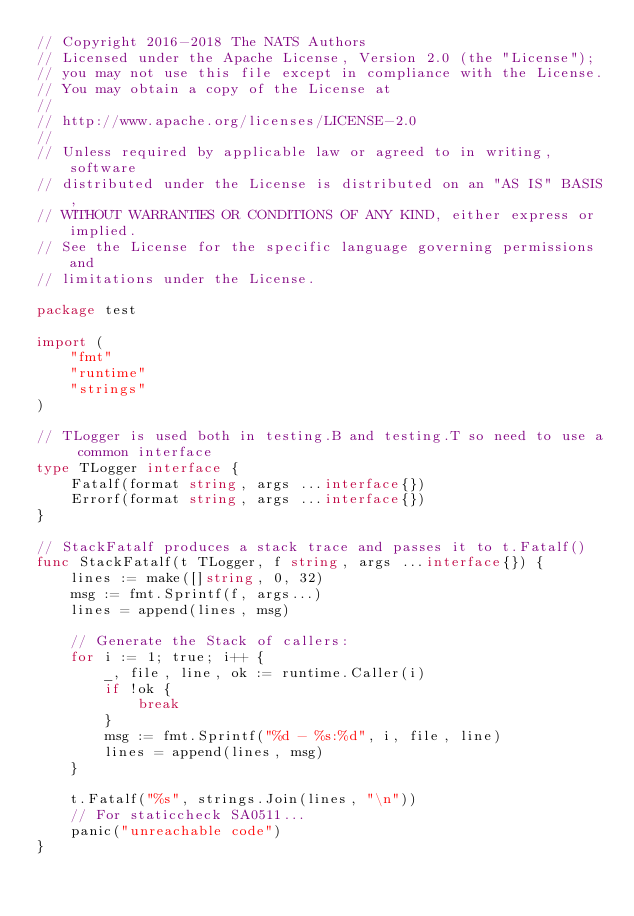<code> <loc_0><loc_0><loc_500><loc_500><_Go_>// Copyright 2016-2018 The NATS Authors
// Licensed under the Apache License, Version 2.0 (the "License");
// you may not use this file except in compliance with the License.
// You may obtain a copy of the License at
//
// http://www.apache.org/licenses/LICENSE-2.0
//
// Unless required by applicable law or agreed to in writing, software
// distributed under the License is distributed on an "AS IS" BASIS,
// WITHOUT WARRANTIES OR CONDITIONS OF ANY KIND, either express or implied.
// See the License for the specific language governing permissions and
// limitations under the License.

package test

import (
	"fmt"
	"runtime"
	"strings"
)

// TLogger is used both in testing.B and testing.T so need to use a common interface
type TLogger interface {
	Fatalf(format string, args ...interface{})
	Errorf(format string, args ...interface{})
}

// StackFatalf produces a stack trace and passes it to t.Fatalf()
func StackFatalf(t TLogger, f string, args ...interface{}) {
	lines := make([]string, 0, 32)
	msg := fmt.Sprintf(f, args...)
	lines = append(lines, msg)

	// Generate the Stack of callers:
	for i := 1; true; i++ {
		_, file, line, ok := runtime.Caller(i)
		if !ok {
			break
		}
		msg := fmt.Sprintf("%d - %s:%d", i, file, line)
		lines = append(lines, msg)
	}

	t.Fatalf("%s", strings.Join(lines, "\n"))
	// For staticcheck SA0511...
	panic("unreachable code")
}
</code> 